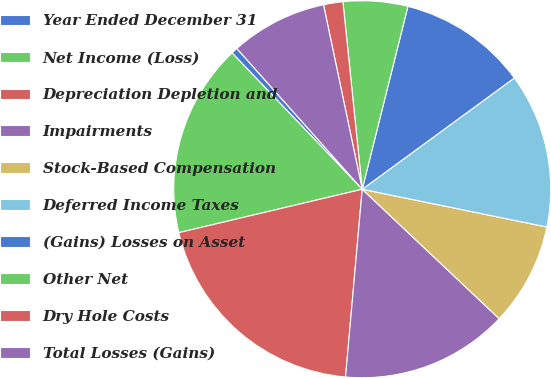Convert chart. <chart><loc_0><loc_0><loc_500><loc_500><pie_chart><fcel>Year Ended December 31<fcel>Net Income (Loss)<fcel>Depreciation Depletion and<fcel>Impairments<fcel>Stock-Based Compensation<fcel>Deferred Income Taxes<fcel>(Gains) Losses on Asset<fcel>Other Net<fcel>Dry Hole Costs<fcel>Total Losses (Gains)<nl><fcel>0.55%<fcel>16.57%<fcel>19.89%<fcel>14.36%<fcel>8.84%<fcel>13.26%<fcel>11.05%<fcel>5.53%<fcel>1.66%<fcel>8.29%<nl></chart> 